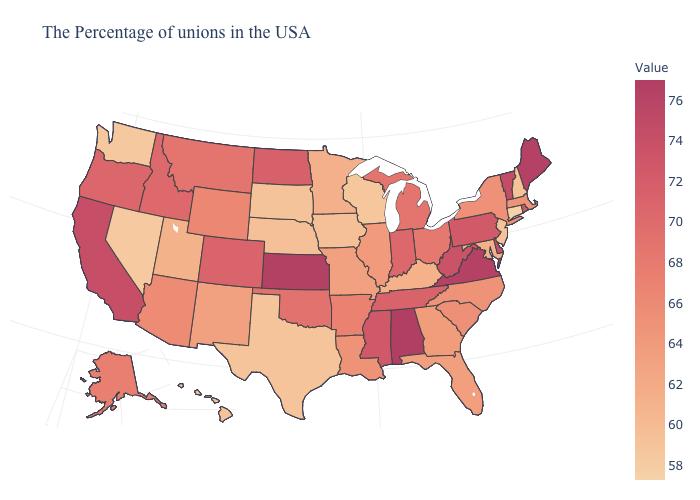Among the states that border Wyoming , does Colorado have the highest value?
Be succinct. Yes. Which states have the lowest value in the Northeast?
Concise answer only. Connecticut. Among the states that border New Jersey , which have the highest value?
Give a very brief answer. Delaware. Among the states that border Iowa , which have the lowest value?
Short answer required. Wisconsin. Among the states that border Indiana , does Illinois have the highest value?
Quick response, please. No. 